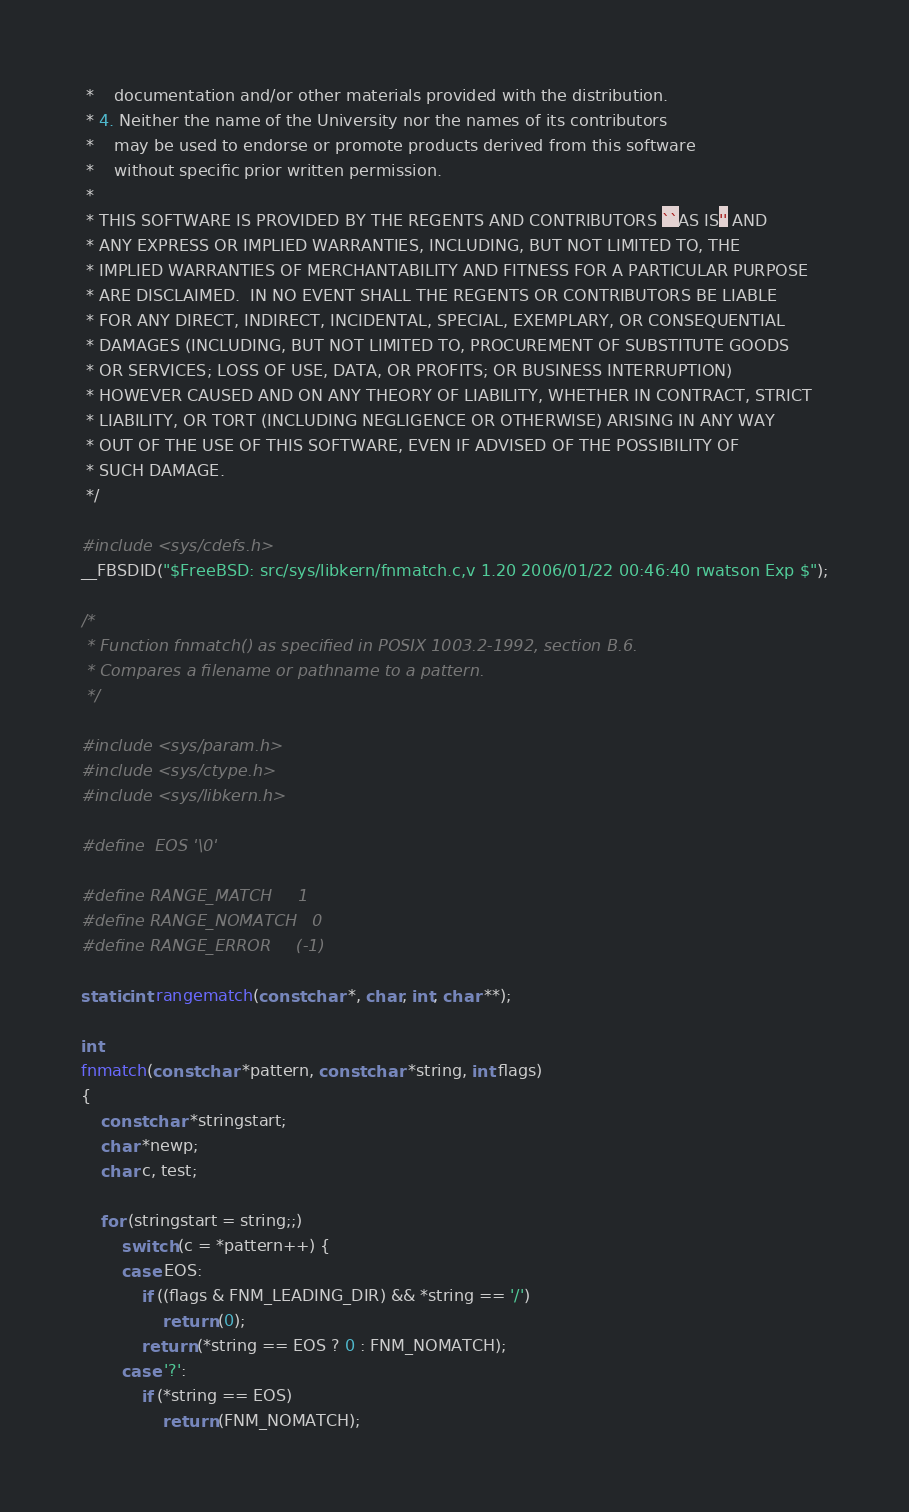<code> <loc_0><loc_0><loc_500><loc_500><_C_> *    documentation and/or other materials provided with the distribution.
 * 4. Neither the name of the University nor the names of its contributors
 *    may be used to endorse or promote products derived from this software
 *    without specific prior written permission.
 *
 * THIS SOFTWARE IS PROVIDED BY THE REGENTS AND CONTRIBUTORS ``AS IS'' AND
 * ANY EXPRESS OR IMPLIED WARRANTIES, INCLUDING, BUT NOT LIMITED TO, THE
 * IMPLIED WARRANTIES OF MERCHANTABILITY AND FITNESS FOR A PARTICULAR PURPOSE
 * ARE DISCLAIMED.  IN NO EVENT SHALL THE REGENTS OR CONTRIBUTORS BE LIABLE
 * FOR ANY DIRECT, INDIRECT, INCIDENTAL, SPECIAL, EXEMPLARY, OR CONSEQUENTIAL
 * DAMAGES (INCLUDING, BUT NOT LIMITED TO, PROCUREMENT OF SUBSTITUTE GOODS
 * OR SERVICES; LOSS OF USE, DATA, OR PROFITS; OR BUSINESS INTERRUPTION)
 * HOWEVER CAUSED AND ON ANY THEORY OF LIABILITY, WHETHER IN CONTRACT, STRICT
 * LIABILITY, OR TORT (INCLUDING NEGLIGENCE OR OTHERWISE) ARISING IN ANY WAY
 * OUT OF THE USE OF THIS SOFTWARE, EVEN IF ADVISED OF THE POSSIBILITY OF
 * SUCH DAMAGE.
 */

#include <sys/cdefs.h>
__FBSDID("$FreeBSD: src/sys/libkern/fnmatch.c,v 1.20 2006/01/22 00:46:40 rwatson Exp $");

/*
 * Function fnmatch() as specified in POSIX 1003.2-1992, section B.6.
 * Compares a filename or pathname to a pattern.
 */

#include <sys/param.h>
#include <sys/ctype.h>
#include <sys/libkern.h>

#define	EOS	'\0'

#define RANGE_MATCH     1
#define RANGE_NOMATCH   0
#define RANGE_ERROR     (-1)

static int rangematch(const char *, char, int, char **);

int
fnmatch(const char *pattern, const char *string, int flags)
{
	const char *stringstart;
	char *newp;
	char c, test;

	for (stringstart = string;;)
		switch (c = *pattern++) {
		case EOS:
			if ((flags & FNM_LEADING_DIR) && *string == '/')
				return (0);
			return (*string == EOS ? 0 : FNM_NOMATCH);
		case '?':
			if (*string == EOS)
				return (FNM_NOMATCH);</code> 